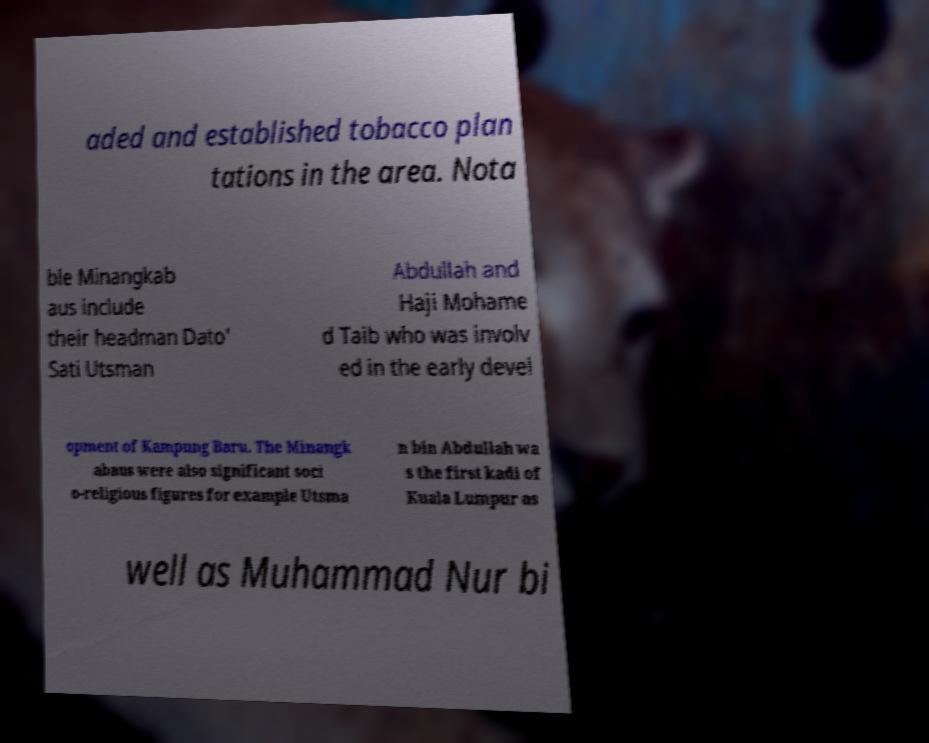Can you accurately transcribe the text from the provided image for me? aded and established tobacco plan tations in the area. Nota ble Minangkab aus include their headman Dato' Sati Utsman Abdullah and Haji Mohame d Taib who was involv ed in the early devel opment of Kampung Baru. The Minangk abaus were also significant soci o-religious figures for example Utsma n bin Abdullah wa s the first kadi of Kuala Lumpur as well as Muhammad Nur bi 